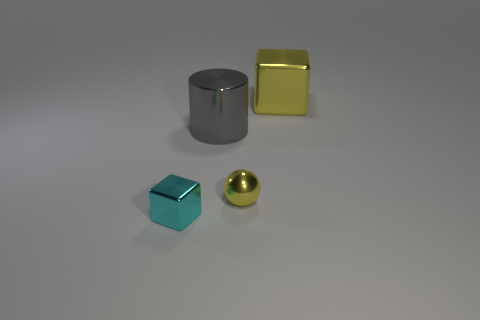Subtract all cyan blocks. How many blocks are left? 1 Add 1 yellow metal blocks. How many yellow metal blocks exist? 2 Add 3 gray things. How many objects exist? 7 Subtract 1 yellow balls. How many objects are left? 3 Subtract all balls. How many objects are left? 3 Subtract 1 cylinders. How many cylinders are left? 0 Subtract all red cubes. Subtract all gray cylinders. How many cubes are left? 2 Subtract all blue cylinders. How many purple balls are left? 0 Subtract all small balls. Subtract all tiny purple cylinders. How many objects are left? 3 Add 4 large things. How many large things are left? 6 